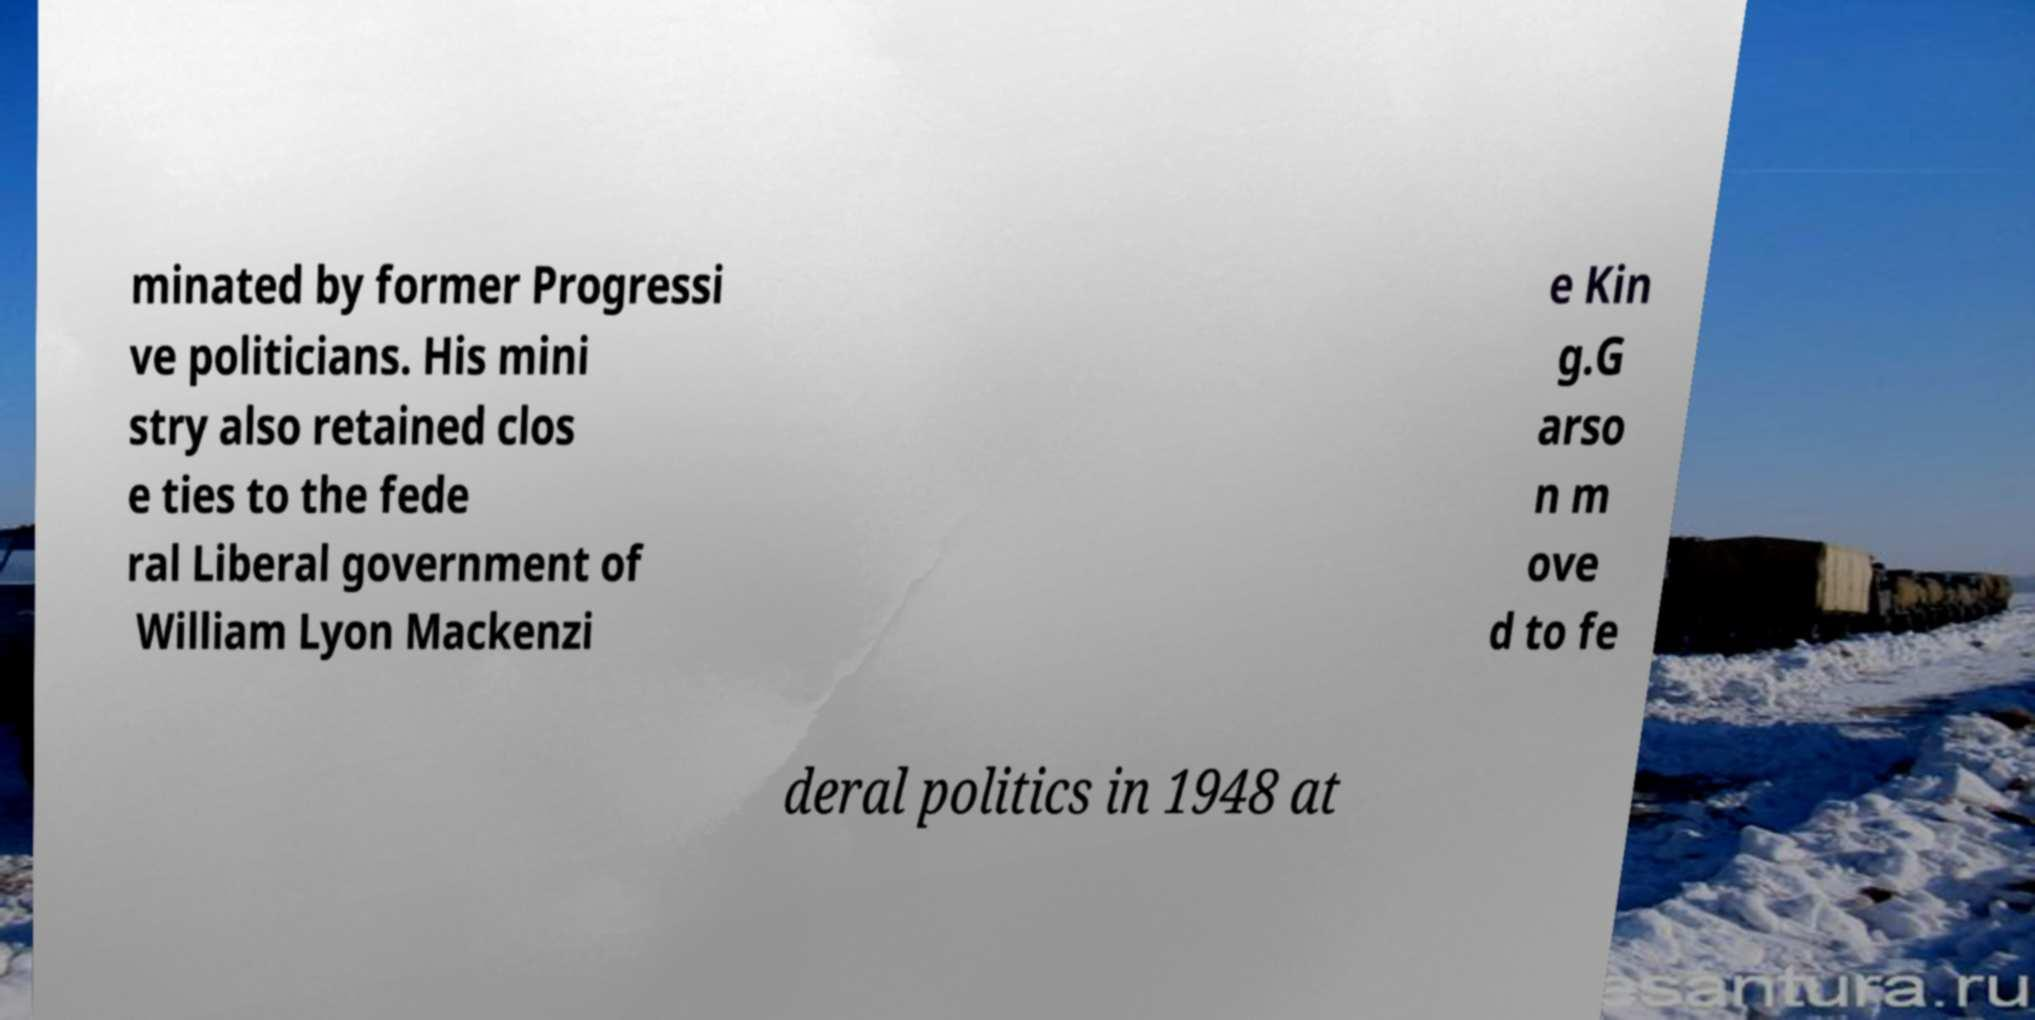There's text embedded in this image that I need extracted. Can you transcribe it verbatim? minated by former Progressi ve politicians. His mini stry also retained clos e ties to the fede ral Liberal government of William Lyon Mackenzi e Kin g.G arso n m ove d to fe deral politics in 1948 at 